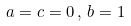Convert formula to latex. <formula><loc_0><loc_0><loc_500><loc_500>a = c = 0 \, , \, b = 1</formula> 